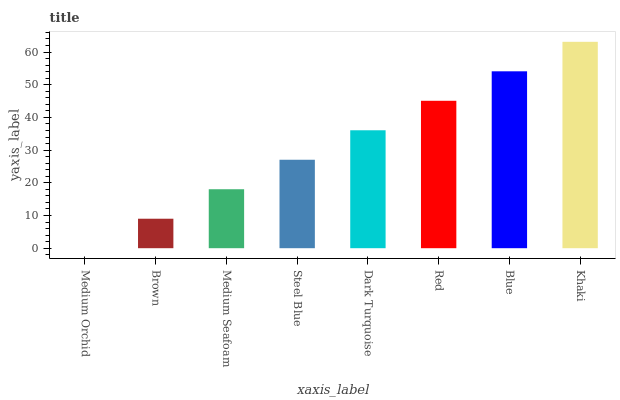Is Medium Orchid the minimum?
Answer yes or no. Yes. Is Khaki the maximum?
Answer yes or no. Yes. Is Brown the minimum?
Answer yes or no. No. Is Brown the maximum?
Answer yes or no. No. Is Brown greater than Medium Orchid?
Answer yes or no. Yes. Is Medium Orchid less than Brown?
Answer yes or no. Yes. Is Medium Orchid greater than Brown?
Answer yes or no. No. Is Brown less than Medium Orchid?
Answer yes or no. No. Is Dark Turquoise the high median?
Answer yes or no. Yes. Is Steel Blue the low median?
Answer yes or no. Yes. Is Red the high median?
Answer yes or no. No. Is Medium Seafoam the low median?
Answer yes or no. No. 